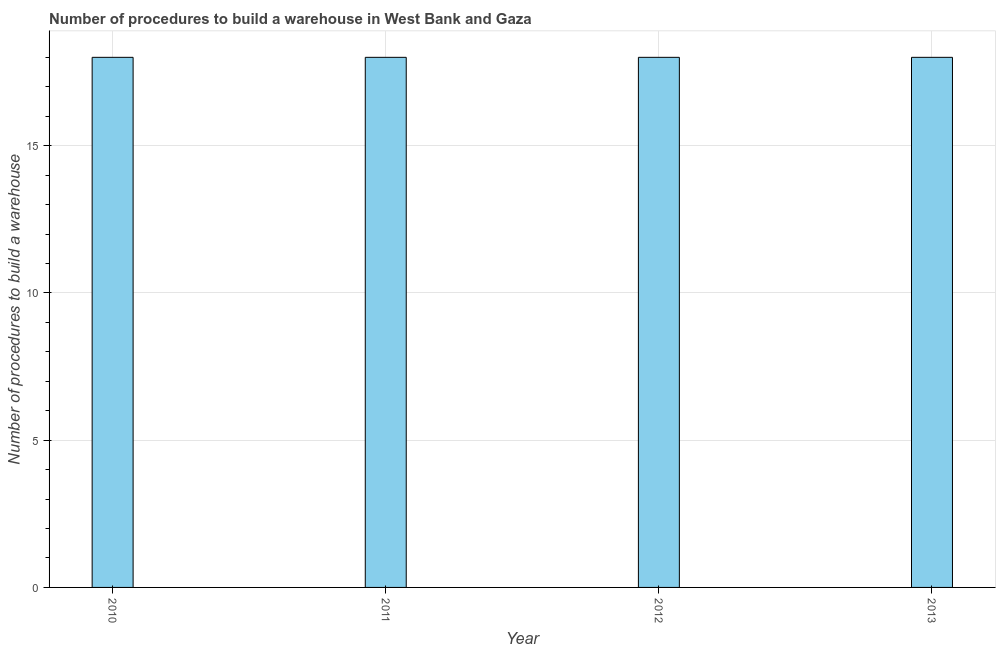Does the graph contain any zero values?
Your answer should be very brief. No. Does the graph contain grids?
Keep it short and to the point. Yes. What is the title of the graph?
Give a very brief answer. Number of procedures to build a warehouse in West Bank and Gaza. What is the label or title of the Y-axis?
Offer a terse response. Number of procedures to build a warehouse. Across all years, what is the minimum number of procedures to build a warehouse?
Provide a short and direct response. 18. What is the sum of the number of procedures to build a warehouse?
Keep it short and to the point. 72. What is the median number of procedures to build a warehouse?
Give a very brief answer. 18. What is the ratio of the number of procedures to build a warehouse in 2010 to that in 2013?
Give a very brief answer. 1. Is the number of procedures to build a warehouse in 2010 less than that in 2013?
Make the answer very short. No. What is the difference between the highest and the second highest number of procedures to build a warehouse?
Your answer should be very brief. 0. What is the difference between the highest and the lowest number of procedures to build a warehouse?
Your answer should be compact. 0. In how many years, is the number of procedures to build a warehouse greater than the average number of procedures to build a warehouse taken over all years?
Your answer should be very brief. 0. Are all the bars in the graph horizontal?
Make the answer very short. No. How many years are there in the graph?
Keep it short and to the point. 4. Are the values on the major ticks of Y-axis written in scientific E-notation?
Offer a very short reply. No. What is the Number of procedures to build a warehouse in 2011?
Offer a terse response. 18. What is the Number of procedures to build a warehouse in 2012?
Offer a very short reply. 18. What is the Number of procedures to build a warehouse in 2013?
Make the answer very short. 18. What is the difference between the Number of procedures to build a warehouse in 2010 and 2012?
Offer a very short reply. 0. What is the ratio of the Number of procedures to build a warehouse in 2010 to that in 2013?
Give a very brief answer. 1. What is the ratio of the Number of procedures to build a warehouse in 2011 to that in 2012?
Make the answer very short. 1. What is the ratio of the Number of procedures to build a warehouse in 2012 to that in 2013?
Your answer should be very brief. 1. 